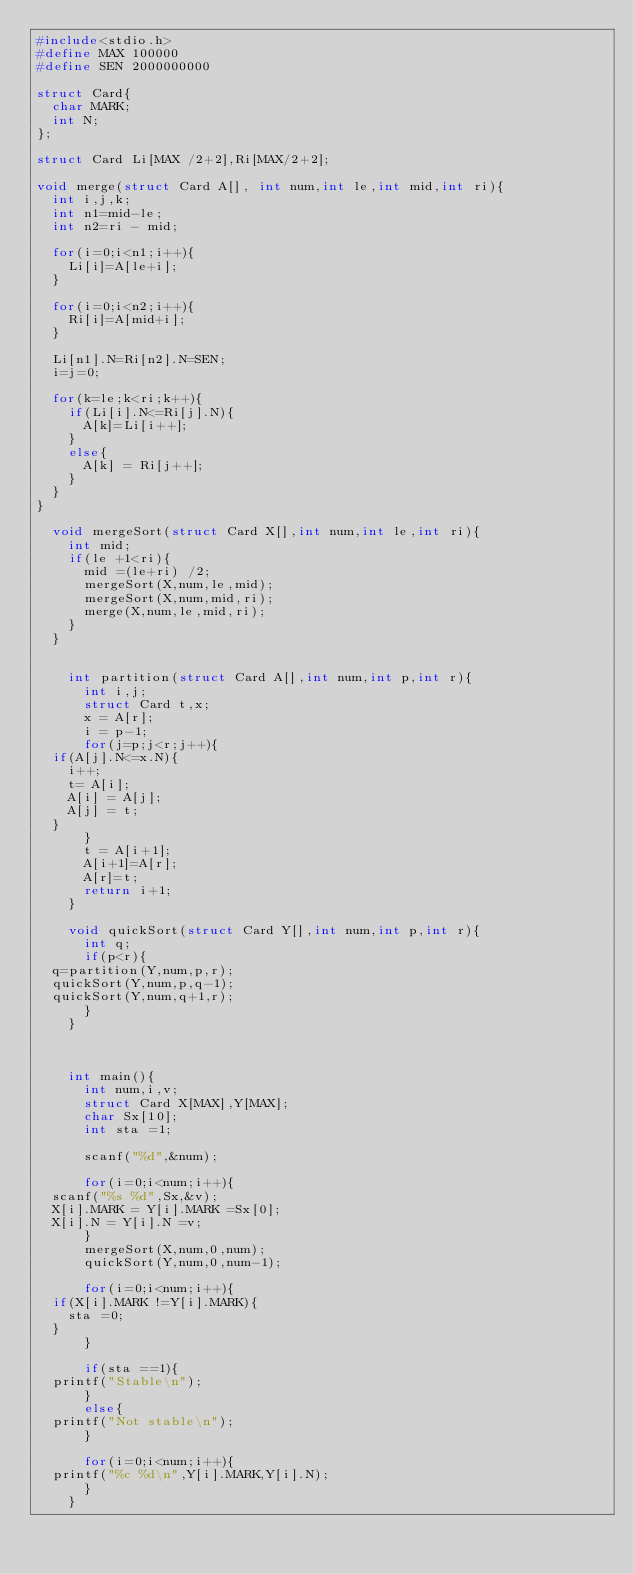<code> <loc_0><loc_0><loc_500><loc_500><_C_>#include<stdio.h>
#define MAX 100000
#define SEN 2000000000

struct Card{
  char MARK;
  int N;
};

struct Card Li[MAX /2+2],Ri[MAX/2+2];

void merge(struct Card A[], int num,int le,int mid,int ri){
  int i,j,k;
  int n1=mid-le;
  int n2=ri - mid;

  for(i=0;i<n1;i++){
    Li[i]=A[le+i];
  }

  for(i=0;i<n2;i++){
    Ri[i]=A[mid+i];
  }

  Li[n1].N=Ri[n2].N=SEN;
  i=j=0;

  for(k=le;k<ri;k++){
    if(Li[i].N<=Ri[j].N){
      A[k]=Li[i++];
    }
    else{
      A[k] = Ri[j++];
    }
  }
}

  void mergeSort(struct Card X[],int num,int le,int ri){
    int mid;
    if(le +1<ri){
      mid =(le+ri) /2;
      mergeSort(X,num,le,mid);
      mergeSort(X,num,mid,ri);
      merge(X,num,le,mid,ri);
    }
  }

  
    int partition(struct Card A[],int num,int p,int r){
      int i,j;
      struct Card t,x;
      x = A[r];
      i = p-1;
      for(j=p;j<r;j++){
	if(A[j].N<=x.N){
	  i++;
	  t= A[i];
	  A[i] = A[j];
	  A[j] = t;
	}
      }
      t = A[i+1];
      A[i+1]=A[r];
      A[r]=t;
      return i+1;
    }

    void quickSort(struct Card Y[],int num,int p,int r){
      int q;
      if(p<r){
	q=partition(Y,num,p,r);
	quickSort(Y,num,p,q-1);
	quickSort(Y,num,q+1,r);
      }
    }


    
    int main(){
      int num,i,v;
      struct Card X[MAX],Y[MAX];
      char Sx[10];
      int sta =1;

      scanf("%d",&num);

      for(i=0;i<num;i++){
	scanf("%s %d",Sx,&v);
	X[i].MARK = Y[i].MARK =Sx[0];
	X[i].N = Y[i].N =v;
      }
      mergeSort(X,num,0,num);
      quickSort(Y,num,0,num-1);

      for(i=0;i<num;i++){
	if(X[i].MARK !=Y[i].MARK){
	  sta =0;
	}
      }

      if(sta ==1){
	printf("Stable\n");
      }
      else{
	printf("Not stable\n");
      }

      for(i=0;i<num;i++){
	printf("%c %d\n",Y[i].MARK,Y[i].N);
      }
    }
  

</code> 